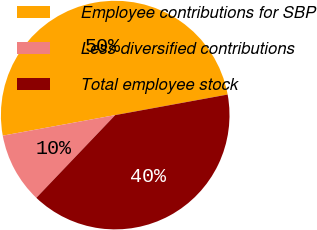<chart> <loc_0><loc_0><loc_500><loc_500><pie_chart><fcel>Employee contributions for SBP<fcel>Less diversified contributions<fcel>Total employee stock<nl><fcel>50.0%<fcel>10.0%<fcel>40.0%<nl></chart> 